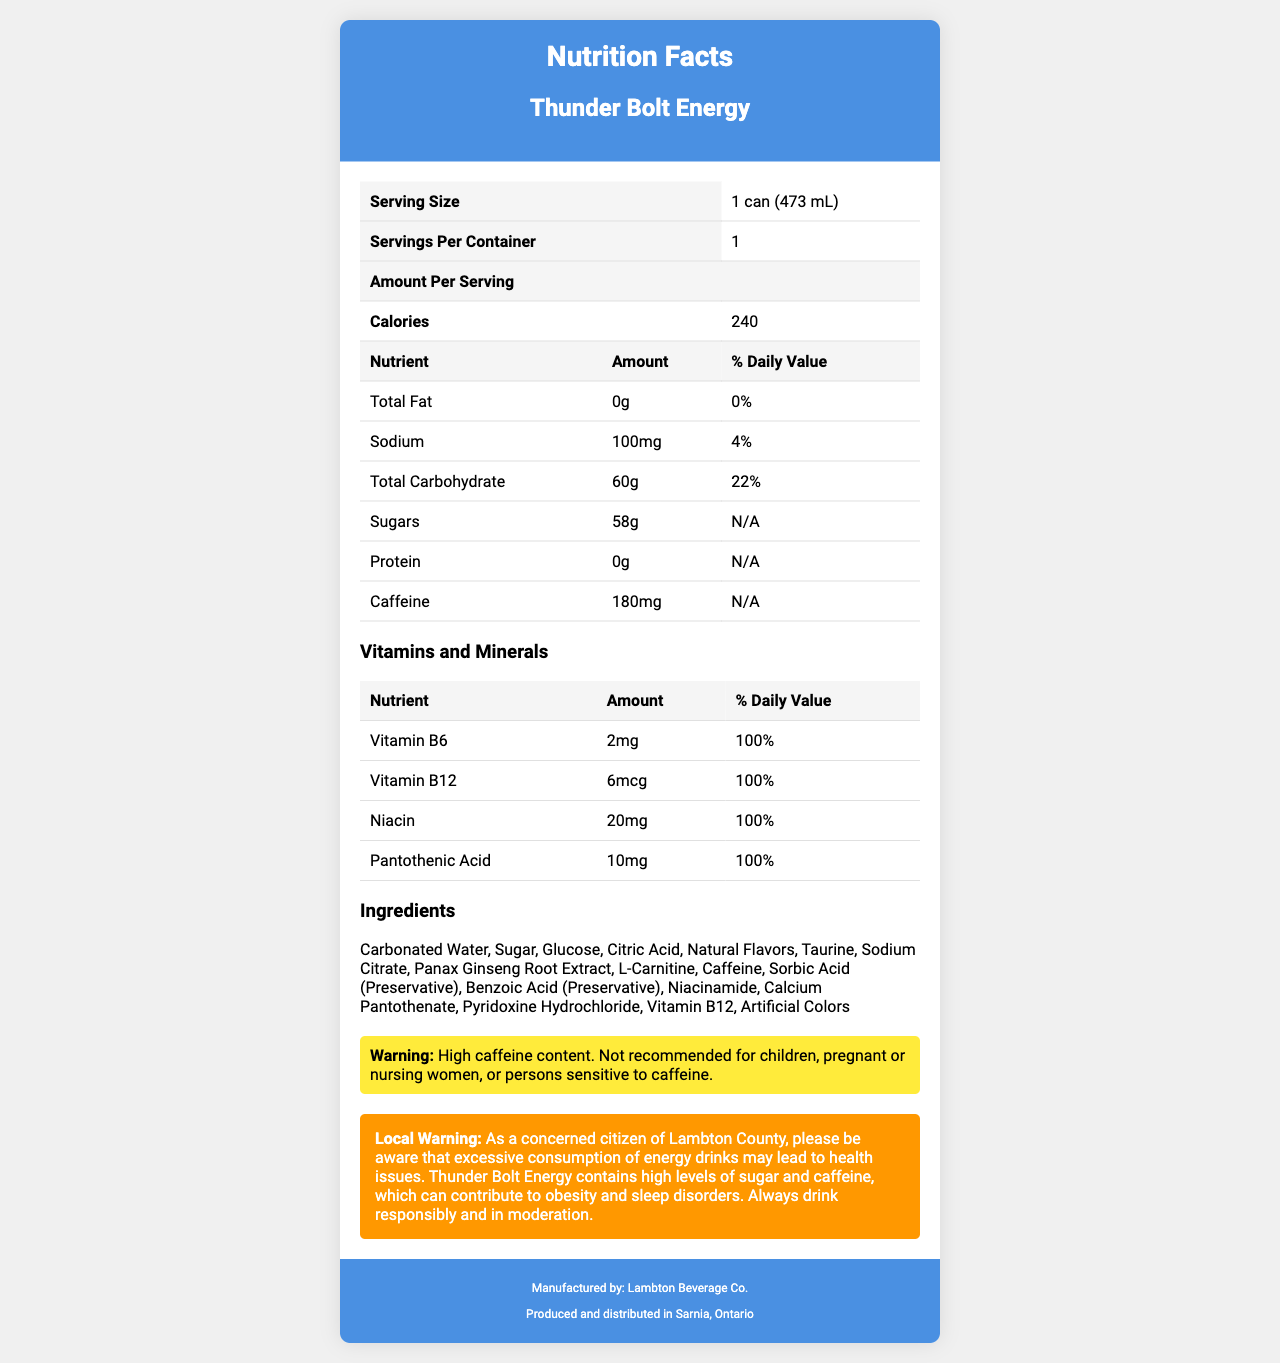what is the serving size of Thunder Bolt Energy? The serving size is clearly indicated in the document as "1 can (473 mL)".
Answer: 1 can (473 mL) how many servings are in each container of Thunder Bolt Energy? The document states that there is 1 serving per container.
Answer: 1 how many calories are there per serving? The amount per serving for calories is listed as 240.
Answer: 240 how much caffeine does Thunder Bolt Energy contain per serving? The document specifies that there is 180mg of caffeine per serving.
Answer: 180mg what is the amount of sugar in Thunder Bolt Energy? The document shows that the amount of sugar per serving is 58g.
Answer: 58g what is the percentage of daily value for sodium in a serving of Thunder Bolt Energy? The daily value percentage for sodium is listed as 4% in the document.
Answer: 4% how much Vitamin B6 is in Thunder Bolt Energy? The amount of Vitamin B6 in the energy drink is stated as 2mg.
Answer: 2mg which ingredient is not present in Thunder Bolt Energy? A. Taurine B. Sodium Nitrate C. Panax Ginseng Root Extract D. L-Carnitine The ingredients list includes Taurine, Panax Ginseng Root Extract, and L-Carnitine but does not mention Sodium Nitrate.
Answer: B what company manufactures Thunder Bolt Energy? A. Lambton Beverage Co. B. Ontario Drinks Inc. C. Sarnia Producers Ltd. The manufacturer of Thunder Bolt Energy is Lambton Beverage Co., as stated in the document.
Answer: A which vitamin has the highest daily value percentage in Thunder Bolt Energy? I. Vitamin B6 II. Vitamin B12 III. Niacin IV. Pantothenic Acid All listed vitamins (Vitamin B6, Vitamin B12, Niacin, and Pantothenic Acid) have 100% daily value, but Niacin is explicitly highlighted in the options.
Answer: III does Thunder Bolt Energy contain any protein? The document indicates that the amount of protein per serving is 0g.
Answer: No summarize the nutritional profile of Thunder Bolt Energy. The nutritional profile is summarized based on all the key nutritional and ingredient information given in the document.
Answer: Thunder Bolt Energy is a high-caffeine energy drink with 240 calories per serving, containing 58g of sugar and 180mg of caffeine. It provides 100% of the daily value for several vitamins including Vitamin B6, Vitamin B12, Niacin, and Pantothenic Acid. It has no fat and no protein and contains 100mg of sodium. what is the effect of excessive consumption of energy drinks as mentioned in the local warning? The local warning in the document specifically mentions these potential health issues.
Answer: Excessive consumption may lead to health issues such as obesity and sleep disorders. what is the contact number of the manufacturing company? The document does not provide any contact number for the manufacturing company Lambton Beverage Co.
Answer: Cannot be determined 